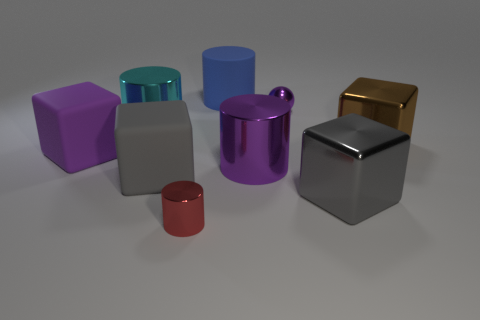Does the purple metallic object in front of the small ball have the same size as the gray thing that is right of the blue object?
Offer a very short reply. Yes. The tiny cylinder is what color?
Ensure brevity in your answer.  Red. There is a small shiny thing that is in front of the brown shiny cube; is its shape the same as the large blue thing?
Your answer should be compact. Yes. What is the brown object made of?
Your answer should be very brief. Metal. The cyan shiny thing that is the same size as the blue matte cylinder is what shape?
Make the answer very short. Cylinder. Is there a cylinder of the same color as the ball?
Your answer should be very brief. Yes. Does the metal sphere have the same color as the big metallic cylinder that is right of the red metallic cylinder?
Your answer should be very brief. Yes. There is a rubber object on the right side of the small object in front of the brown metal cube; what is its color?
Provide a succinct answer. Blue. There is a large cube that is behind the purple object that is to the left of the big blue cylinder; are there any rubber things behind it?
Offer a very short reply. Yes. The big block that is the same material as the brown thing is what color?
Your answer should be compact. Gray. 